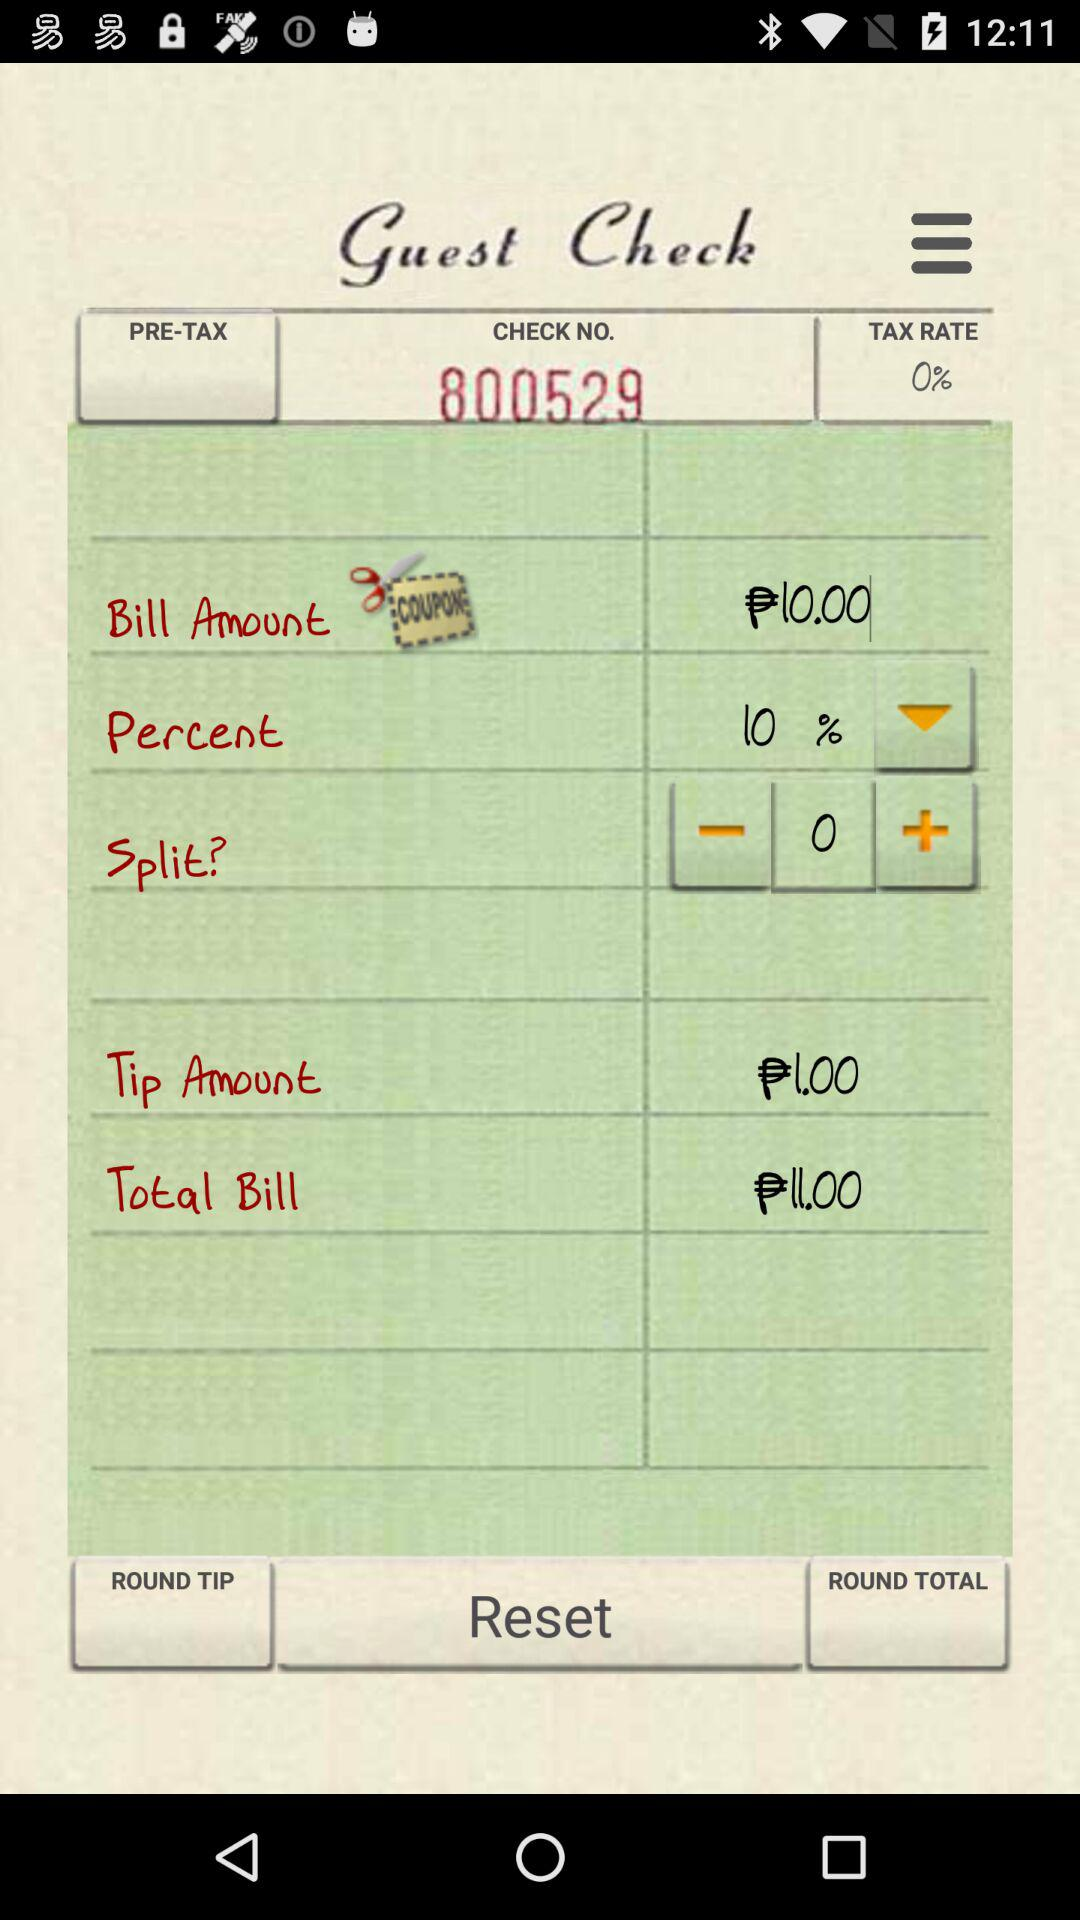What is the selected percent? The selected percent is 10. 